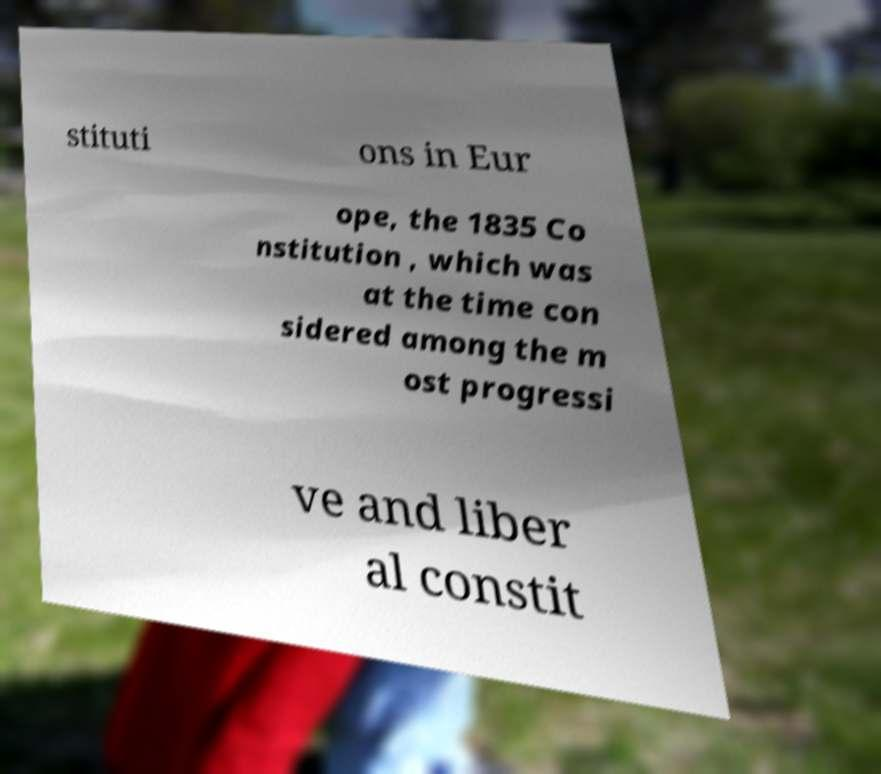Could you assist in decoding the text presented in this image and type it out clearly? stituti ons in Eur ope, the 1835 Co nstitution , which was at the time con sidered among the m ost progressi ve and liber al constit 